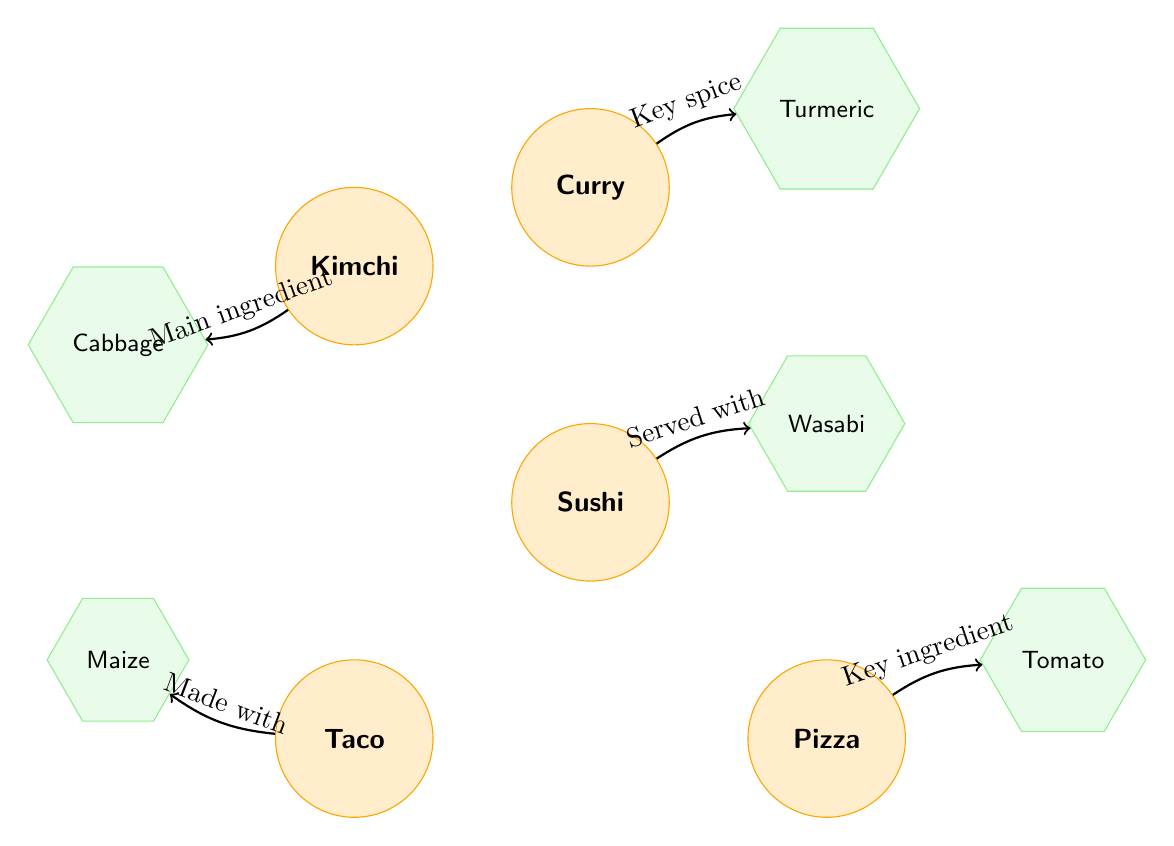What food is served with wasabi? The diagram shows an arrow pointing from the food node "Sushi" to the ingredient node "Wasabi" with the label "Served with". This indicates that sushi is the food that is served with wasabi.
Answer: Sushi What is the main ingredient of kimchi? The diagram has an arrow connecting the food node "Kimchi" to the ingredient node "Cabbage" with the label "Main ingredient". This shows that cabbage is the primary ingredient in kimchi.
Answer: Cabbage How many food nodes are there in the diagram? By counting the circles labeled as food, I find there are five nodes: Sushi, Taco, Pizza, Kimchi, and Curry. Therefore, the total number of food nodes is five.
Answer: 5 Which food has maize as a key ingredient? The food node "Taco" is connected to the ingredient node "Maize" with the label "Made with". This indicates that maize is used to make tacos.
Answer: Taco What is the key spice for curry? The food node "Curry" is connected to the ingredient node "Turmeric" with the label "Key spice". Thus, turmeric is identified as the key spice used in curry.
Answer: Turmeric How many total connections are made in this diagram? There are five arrows showing relationships between food and ingredient nodes in the diagram. By counting each connection, I conclude that there are a total of five connections.
Answer: 5 Which food item is connected to tomato? The food node "Pizza" is linked to the ingredient node "Tomato" with the label "Key ingredient". This points out that tomatoes are essential in making pizza.
Answer: Pizza What ingredient is served with sushi? The connection from "Sushi" to "Wasabi" labeled "Served with" indicates that wasabi is the ingredient served with sushi.
Answer: Wasabi Which food is associated with turmeric? The food node "Curry" points to the ingredient node "Turmeric" with the label "Key spice", indicating that curry is the dish associated with turmeric as a spice.
Answer: Curry 